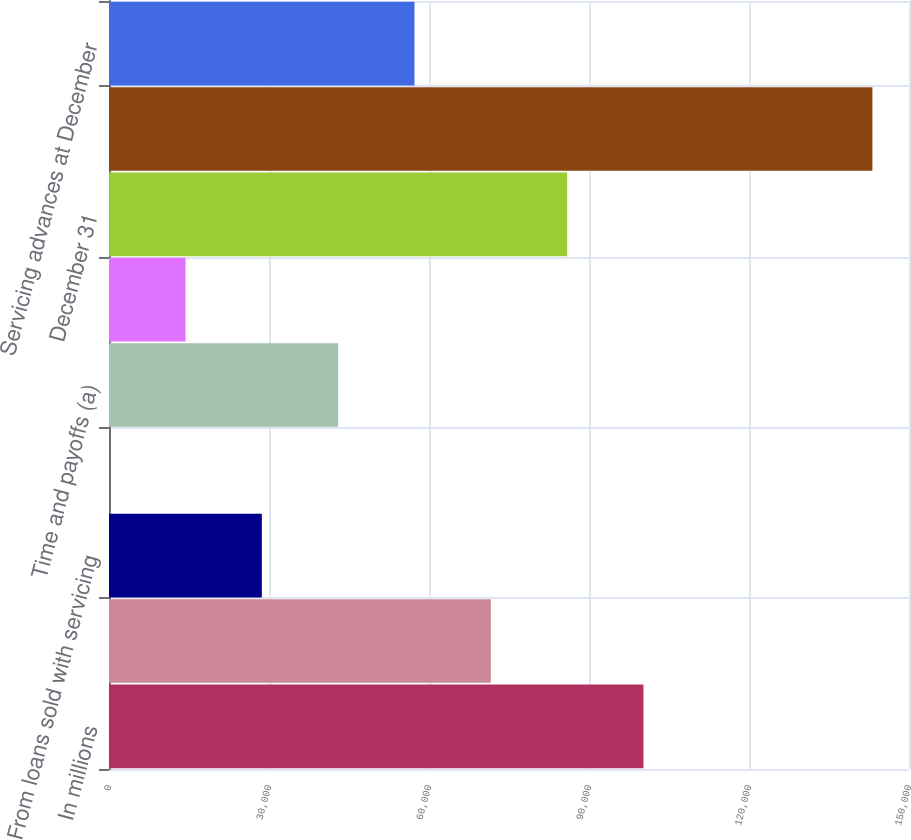Convert chart. <chart><loc_0><loc_0><loc_500><loc_500><bar_chart><fcel>In millions<fcel>January 1<fcel>From loans sold with servicing<fcel>Purchases<fcel>Time and payoffs (a)<fcel>Other (b)<fcel>December 31<fcel>Related unpaid principal<fcel>Servicing advances at December<nl><fcel>100208<fcel>71587.5<fcel>28656.6<fcel>36<fcel>42966.9<fcel>14346.3<fcel>85897.8<fcel>143139<fcel>57277.2<nl></chart> 